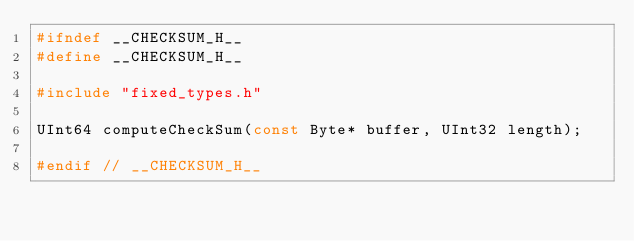Convert code to text. <code><loc_0><loc_0><loc_500><loc_500><_C_>#ifndef __CHECKSUM_H__
#define __CHECKSUM_H__

#include "fixed_types.h"

UInt64 computeCheckSum(const Byte* buffer, UInt32 length);

#endif // __CHECKSUM_H__
</code> 